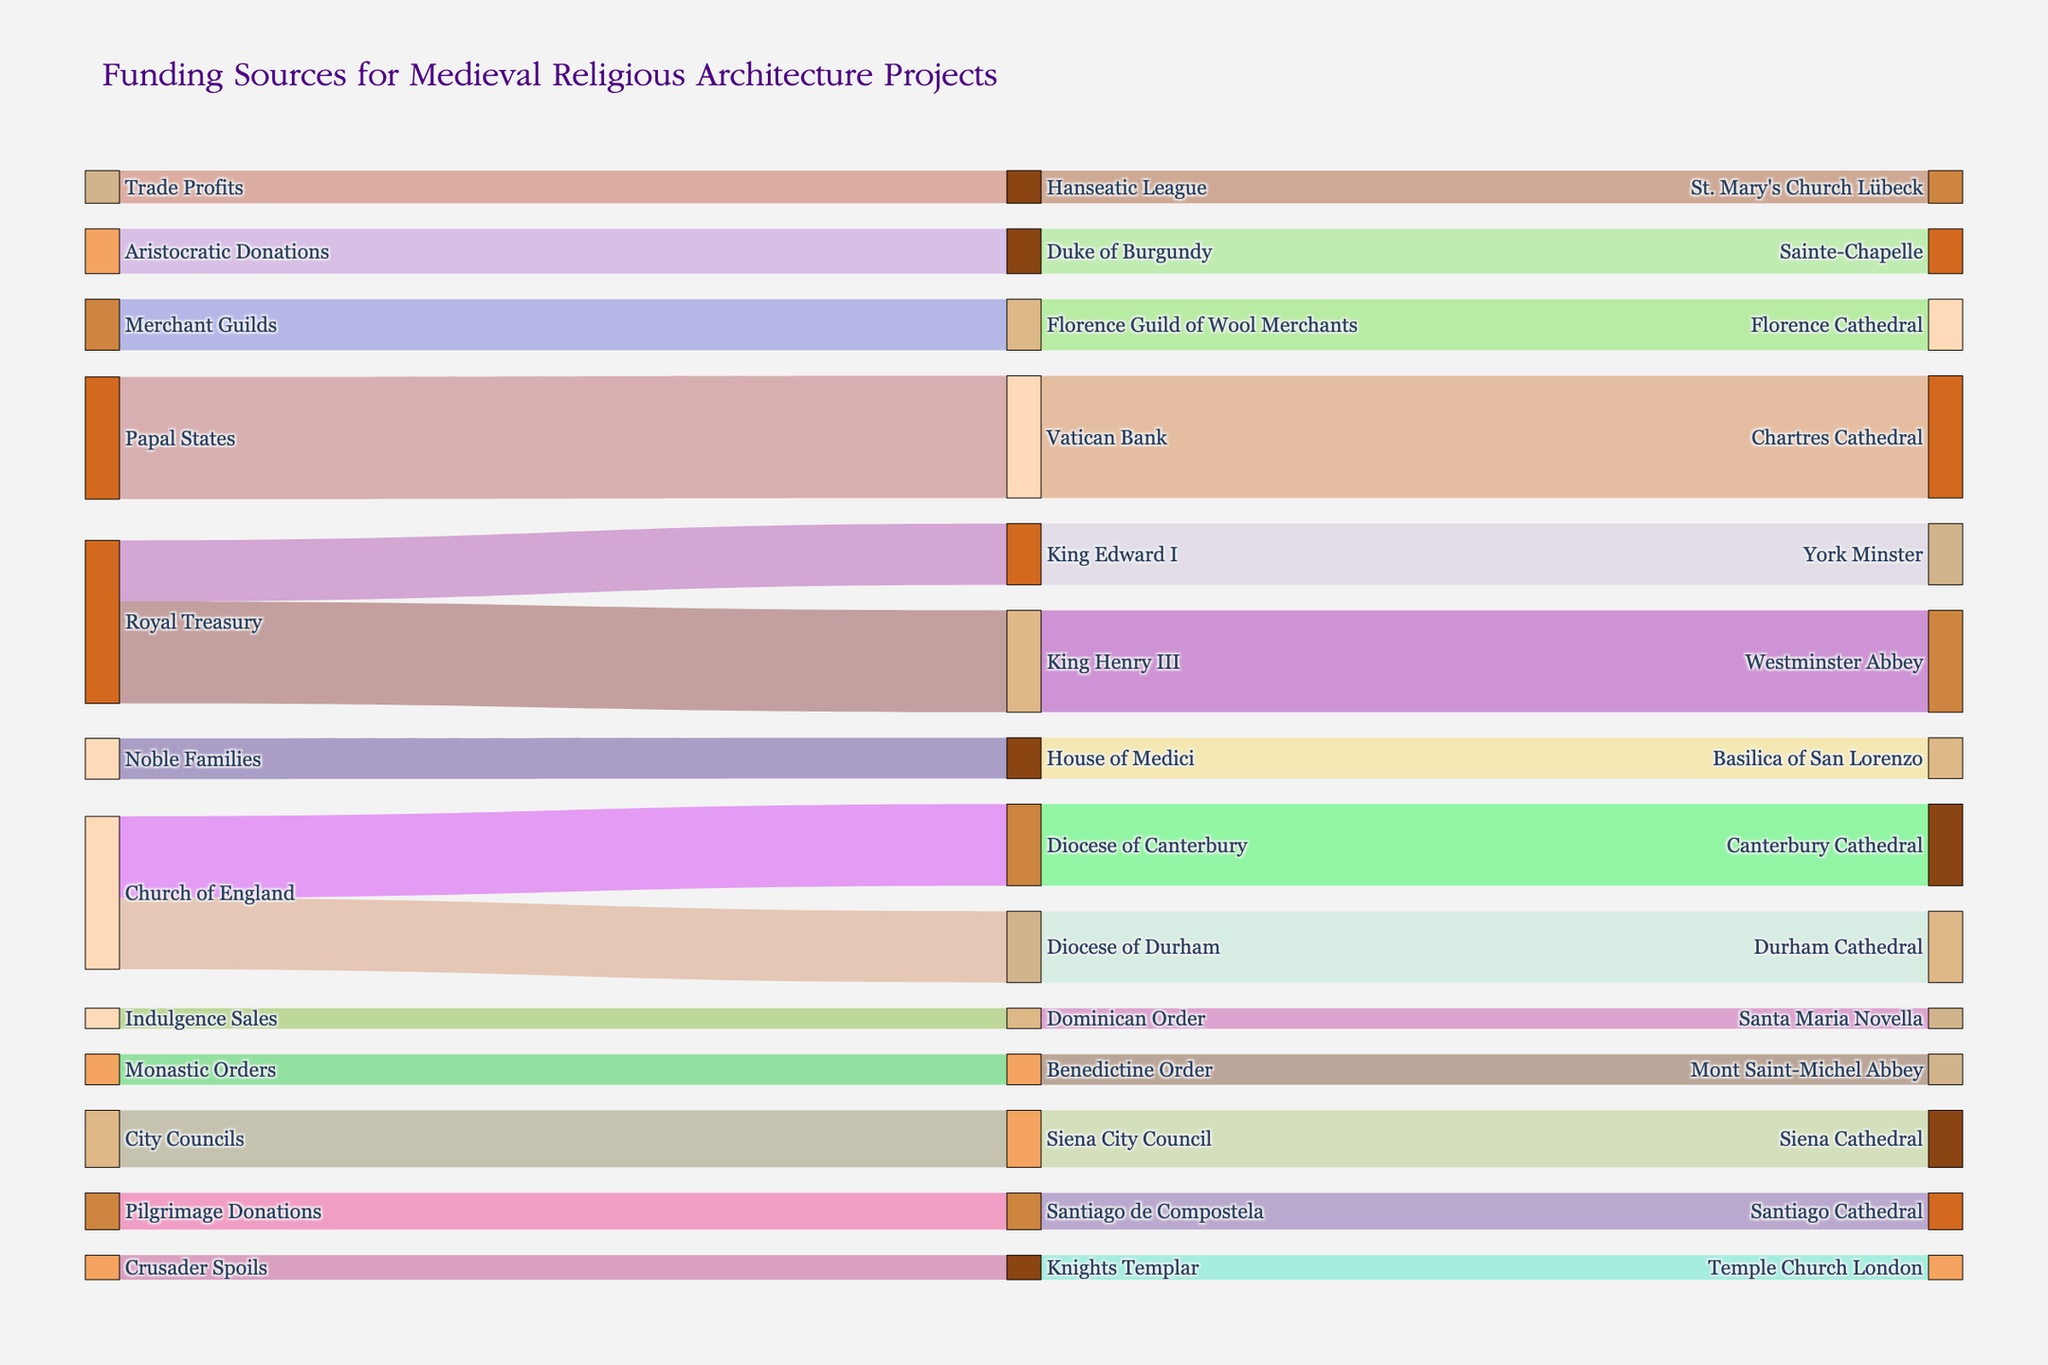What is the title of the Sankey Diagram? The title of the diagram is displayed at the top of the figure, typically in a larger and more prominent font size and style.
Answer: Funding Sources for Medieval Religious Architecture Projects How many intermediary nodes are associated with Royal Treasury? To find the number of intermediary nodes, look at how many distinct nodes are connected directly from "Royal Treasury".
Answer: 2 Which cathedral received the most funding and from which source? Identify the destination node with the highest value and trace back to the source node.
Answer: Chartres Cathedral, Papal States Comparing King Henry III and King Edward I, who directed more funds and to which project? Check the Sankey diagram for the values associated with King Henry III and King Edward I and their respective destination nodes.
Answer: King Henry III, Westminster Abbey What is the total amount of funding provided by Church of England through its various dioceses? Sum the values of all flows originating from Church of England's dioceses to their respective destination nodes.
Answer: 750000 Calculate the average donation amount provided by the Church of England and Royal Treasury combined. Sum the values from the Church of England and Royal Treasury and then divide by the number of donations made by those sources.
Answer: 387500 Which projects received funding from multiple intermediate nodes? Identify the destination nodes that have more than one connection from different intermediary nodes.
Answer: None Which intermediary node between King's Treasury and Florence Guild of Wool Merchants received more funding overall? Sum the incoming values for the intermediary nodes "King's Treasury" and "Florence Guild of Wool Merchants", then compare the totals.
Answer: King's Treasury How does the value of funding from pilgrimage donations compare to crusader spoils? Compare the values next to Santiago de Compostela and Knights Templar.
Answer: Pilgrimage Donations are 60000 more What is the combined funding amount received by York Minster and Durham Cathedral? Add the values directed to both York Minster and Durham Cathedral.
Answer: 650000 